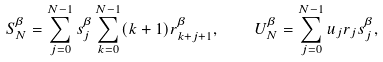<formula> <loc_0><loc_0><loc_500><loc_500>S _ { N } ^ { \beta } = \sum _ { j = 0 } ^ { N - 1 } s _ { j } ^ { \beta } \sum _ { k = 0 } ^ { N - 1 } ( k + 1 ) r _ { k + j + 1 } ^ { \beta } , \quad U _ { N } ^ { \beta } = \sum _ { j = 0 } ^ { N - 1 } u _ { j } r _ { j } s _ { j } ^ { \beta } ,</formula> 